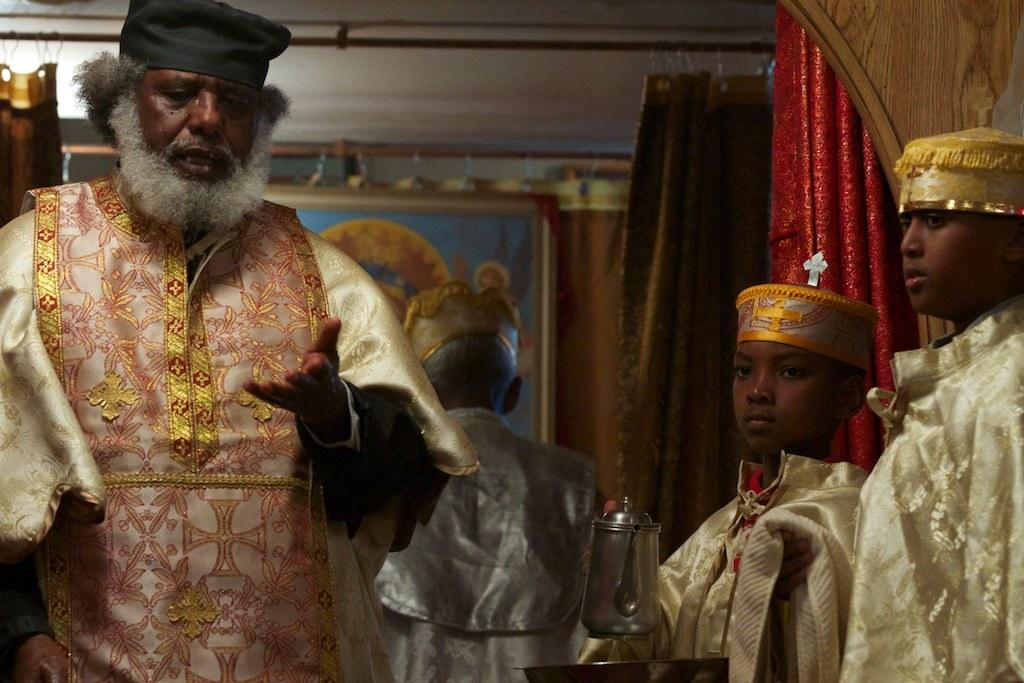How many people are in the image? There are four persons in the image. What are the persons doing in the image? The persons are standing. What object can be seen in the image besides the people? There is a kettle in the image. What can be seen in the background of the image? There are curtains in the background of the image. What type of attention is the flag receiving in the image? There is no flag present in the image, so it cannot receive any attention. How many rings are visible on the persons' fingers in the image? There is no mention of rings or fingers in the image, so it is not possible to determine the number of rings. 